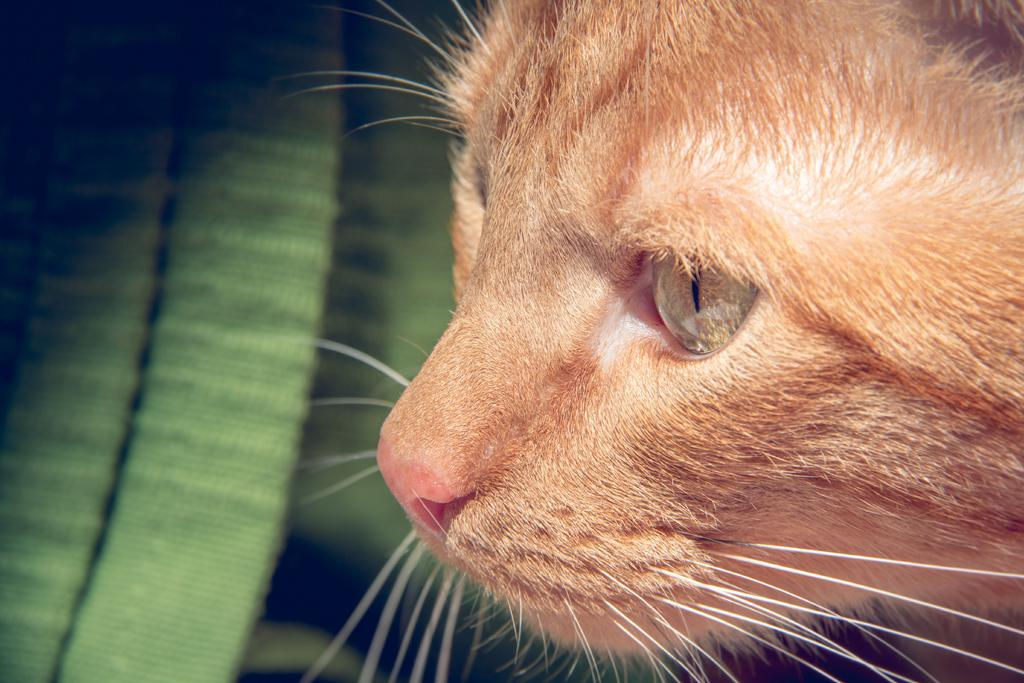What type of living creature is present in the image? There is an animal in the image. Can you describe the background of the image? There is a cloth in the background of the image. How many beds are visible in the image? There are no beds present in the image. What type of side dish is being served with the animal in the image? There is no side dish or food present in the image; it only features an animal and a cloth in the background. 